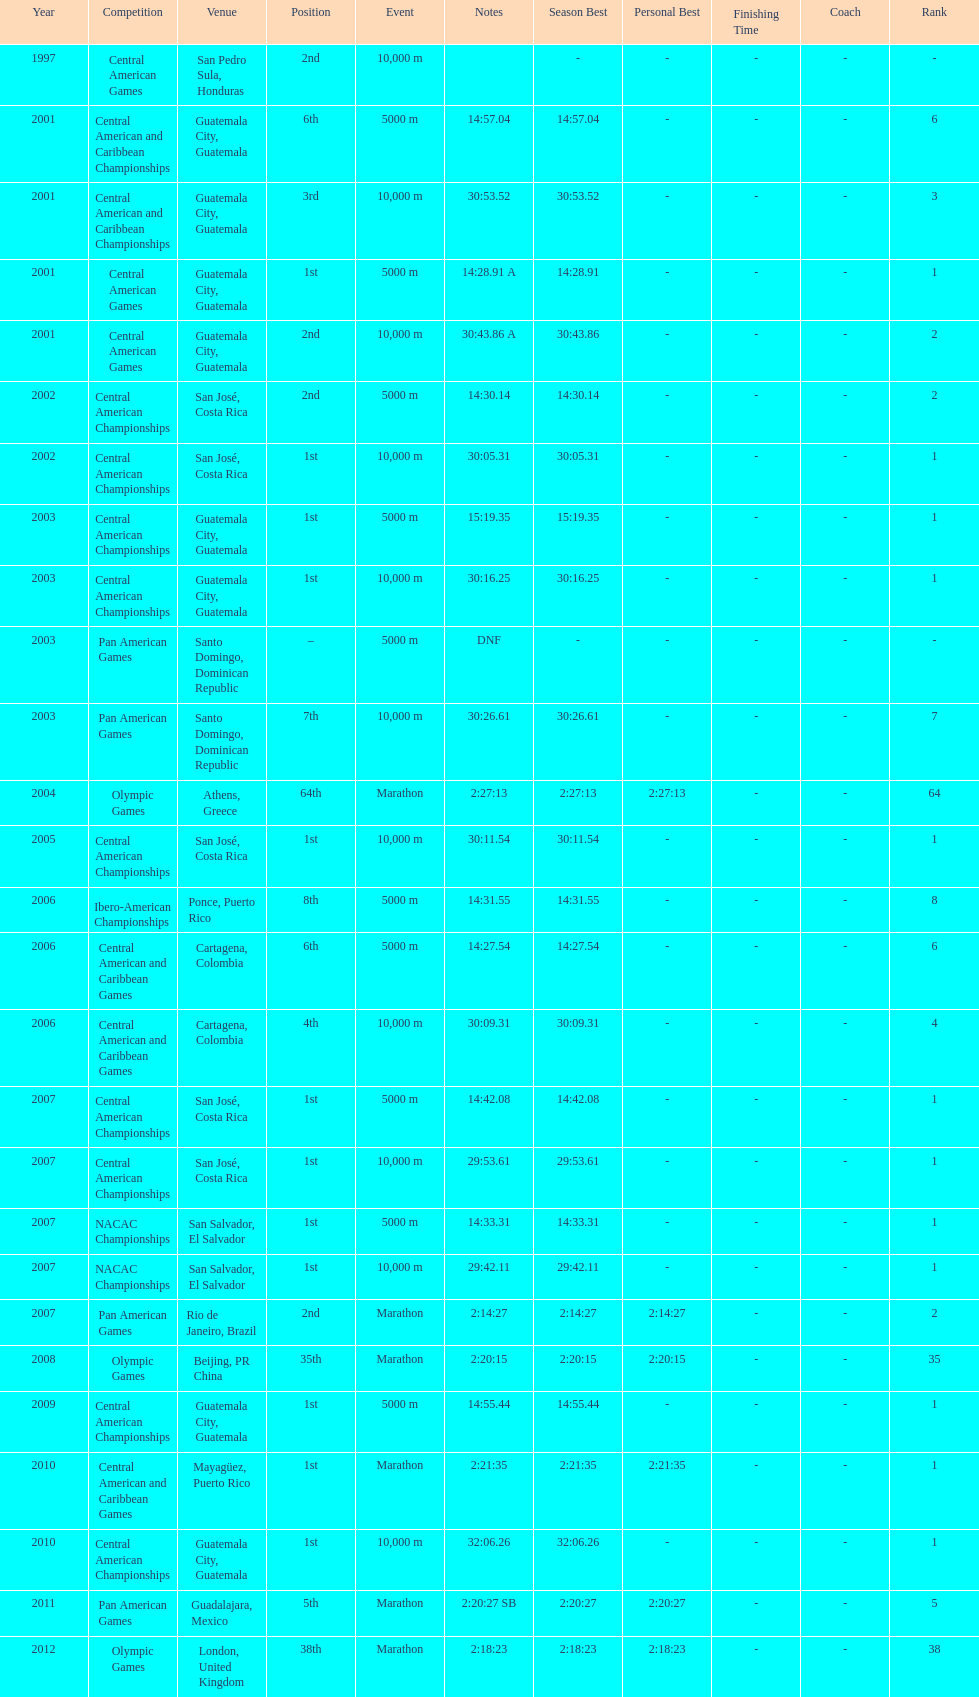What was the first competition this competitor competed in? Central American Games. 